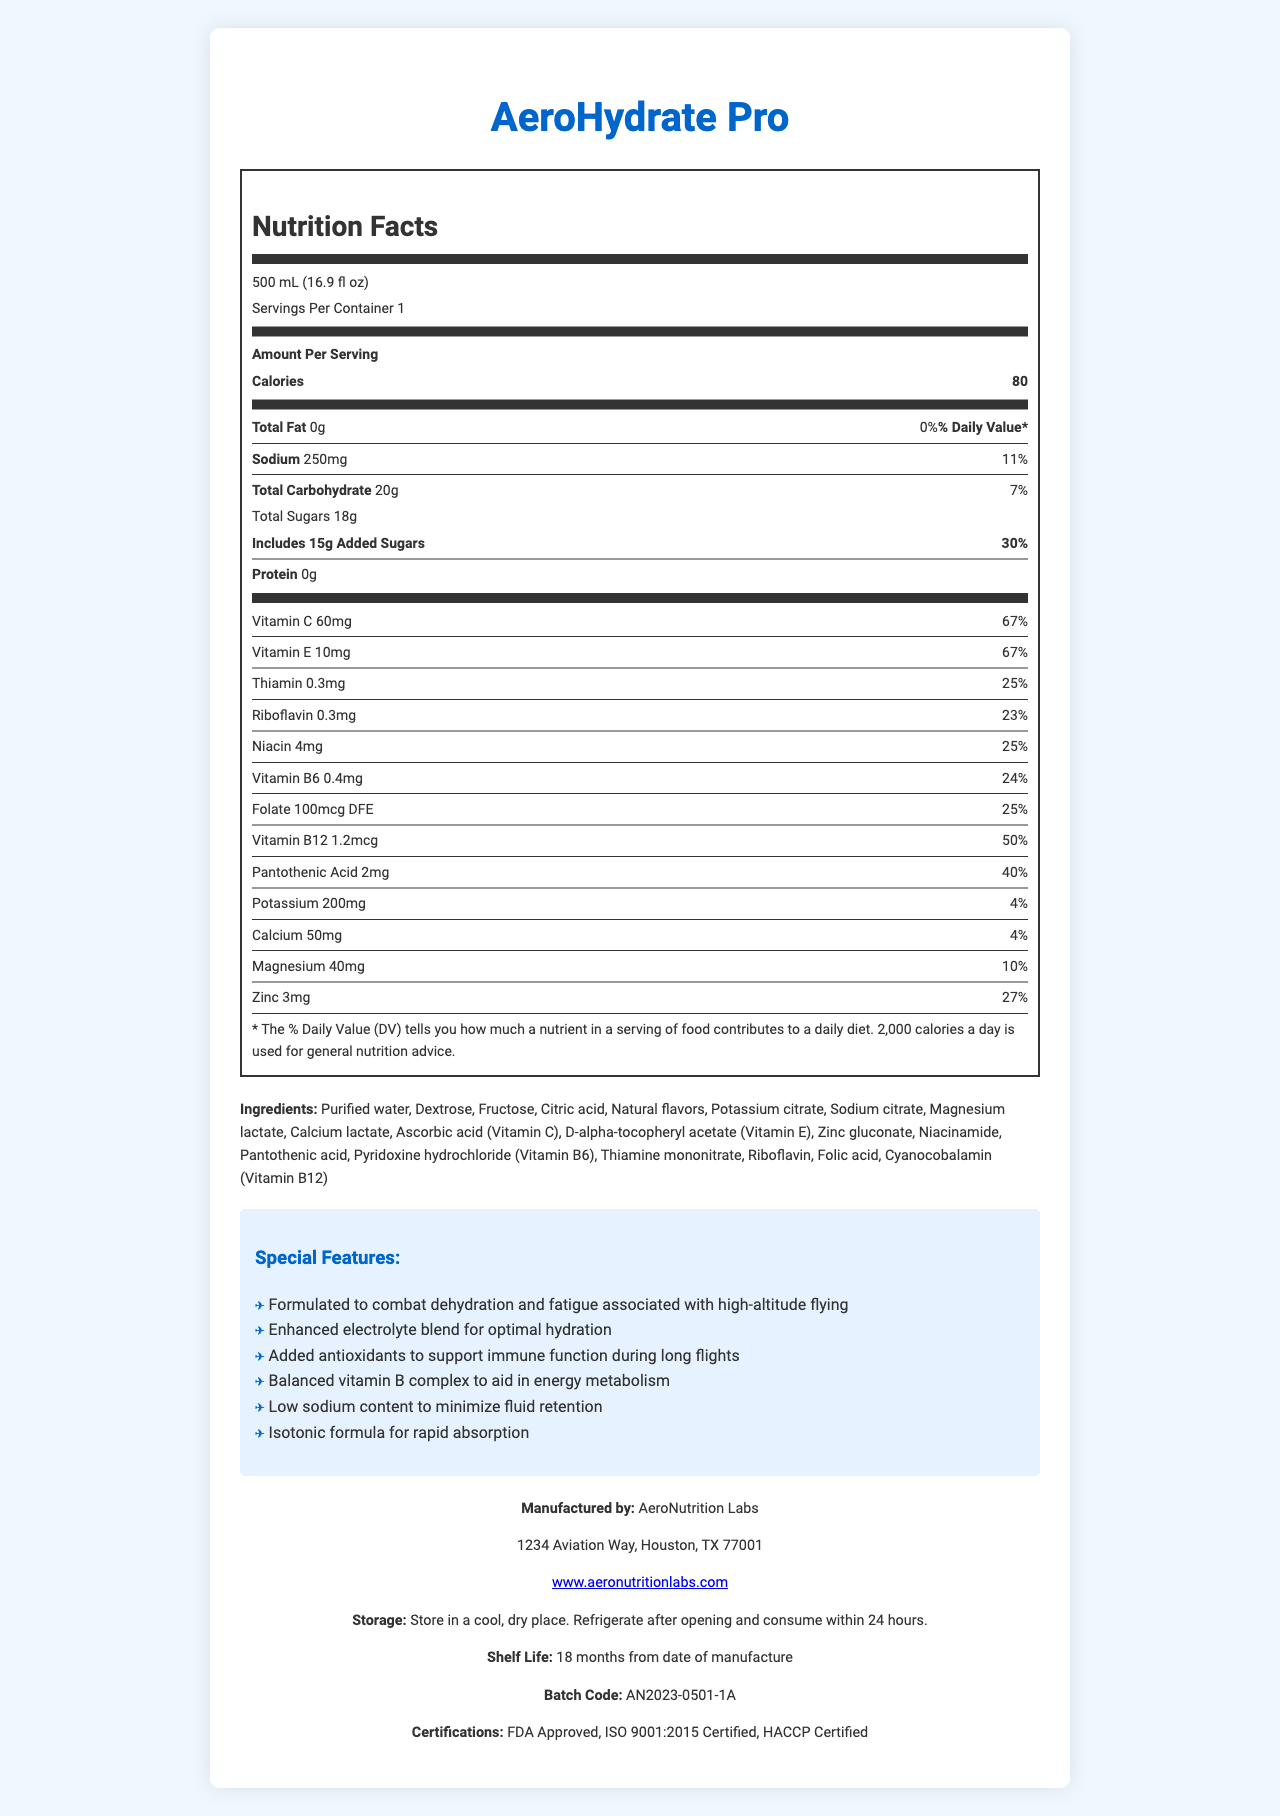What is the serving size of AeroHydrate Pro? The document clearly states that the serving size is 500 mL (16.9 fl oz).
Answer: 500 mL (16.9 fl oz) How many calories are in a serving of AeroHydrate Pro? The document indicates that each serving contains 80 calories.
Answer: 80 calories Name two ingredients listed in AeroHydrate Pro? The document lists multiple ingredients, including purified water and dextrose.
Answer: Purified water, Dextrose What is the percentage of daily value of Vitamin C in AeroHydrate Pro? The document states that Vitamin C has a daily value of 67%.
Answer: 67% How much sodium is in each serving of AeroHydrate Pro? The document indicates that each serving contains 250 mg of sodium.
Answer: 250 mg What is special about AeroHydrate Pro? One of the special features listed is that it is formulated to combat dehydration and fatigue associated with high-altitude flying.
Answer: Formulated to combat dehydration and fatigue associated with high-altitude flying What certifications does AeroHydrate Pro have? A. FDA Approved B. ISO 9001:2015 Certified C. HACCP Certified D. All of the above The document lists that the product is FDA Approved, ISO 9001:2015 Certified, and HACCP Certified.
Answer: D. All of the above Which vitamin in AeroHydrate Pro has the highest daily value percentage? A. Vitamin C B. Thiamin C. Zinc Vitamin C has the highest daily value percentage of 67%.
Answer: A. Vitamin C Is AeroHydrate Pro designed for rapid absorption? The document mentions that it has an isotonic formula for rapid absorption.
Answer: Yes Summarize the primary objective of AeroHydrate Pro. The product is designed specifically to address the hydration and fatigue issues experienced during high-altitude flying. It includes a well-balanced mix of nutrients aimed at energy metabolism, hydration, and immunity, and has a quick absorption formula.
Answer: AeroHydrate Pro is a hydration drink formulated to combat dehydration and fatigue associated with high-altitude flying. It contains a balanced blend of vitamins, minerals, and electrolytes aimed at optimal hydration and energy metabolism. It also features added antioxidants for immune support during long flights and is designed for rapid absorption. What is the average batch size of AeroHydrate Pro? The document does not provide information regarding the average batch size.
Answer: Not enough information Where should AeroHydrate Pro be stored? The document states that AeroHydrate Pro should be stored in a cool, dry place.
Answer: In a cool, dry place Who manufactures AeroHydrate Pro? The manufacturer listed in the document is AeroNutrition Labs.
Answer: AeroNutrition Labs Can AeroHydrate Pro help with energy metabolism? The document states that AeroHydrate Pro contains a balanced vitamin B complex to aid in energy metabolism.
Answer: Yes What is the shelf life of AeroHydrate Pro? The document lists the shelf life as 18 months from the date of manufacture.
Answer: 18 months from date of manufacture What is the total carbohydrate content per serving? The document shows that each serving contains 20 g of total carbohydrates.
Answer: 20 g 